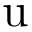Convert formula to latex. <formula><loc_0><loc_0><loc_500><loc_500>u</formula> 